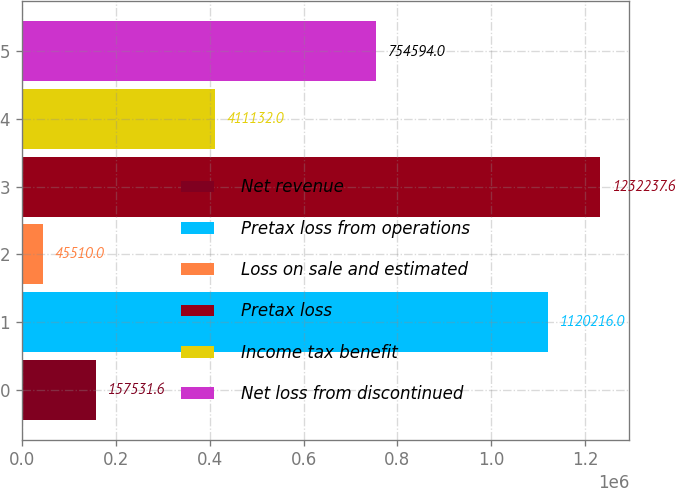<chart> <loc_0><loc_0><loc_500><loc_500><bar_chart><fcel>Net revenue<fcel>Pretax loss from operations<fcel>Loss on sale and estimated<fcel>Pretax loss<fcel>Income tax benefit<fcel>Net loss from discontinued<nl><fcel>157532<fcel>1.12022e+06<fcel>45510<fcel>1.23224e+06<fcel>411132<fcel>754594<nl></chart> 